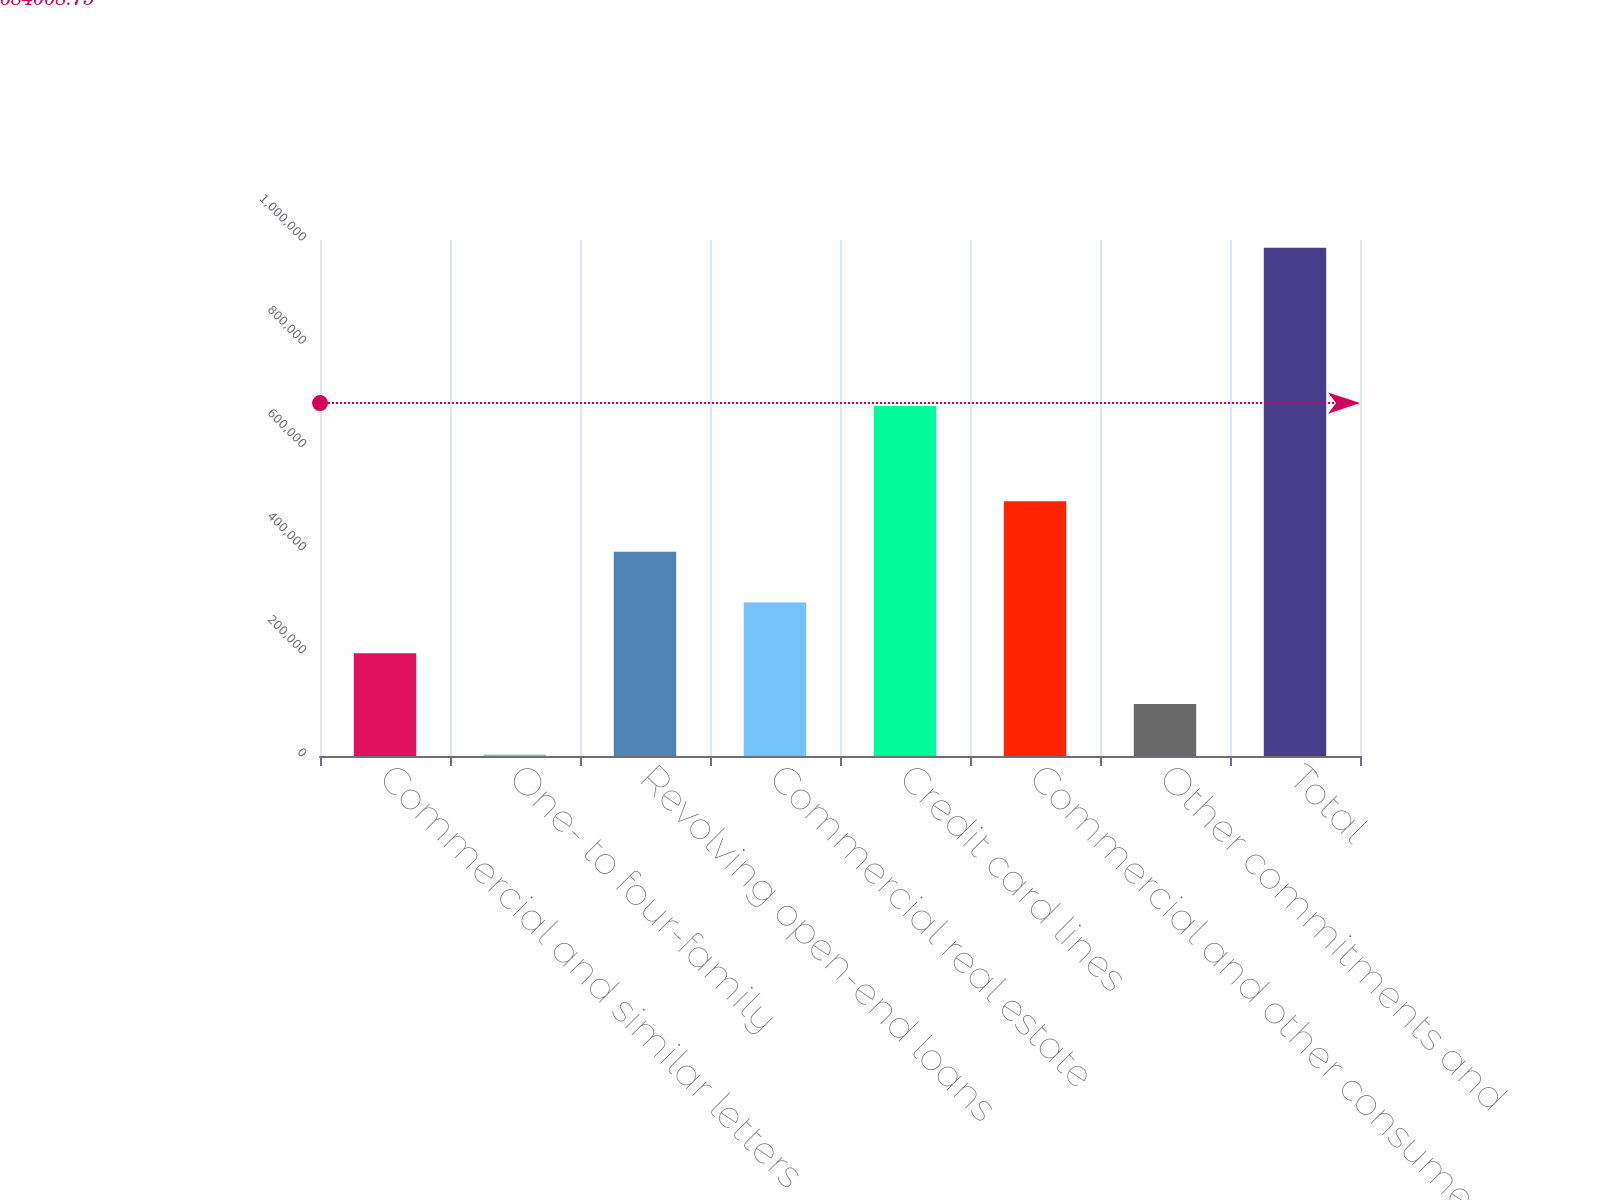Convert chart. <chart><loc_0><loc_0><loc_500><loc_500><bar_chart><fcel>Commercial and similar letters<fcel>One- to four-family<fcel>Revolving open-end loans<fcel>Commercial real estate<fcel>Credit card lines<fcel>Commercial and other consumer<fcel>Other commitments and<fcel>Total<nl><fcel>199174<fcel>2674<fcel>395674<fcel>297424<fcel>678300<fcel>493924<fcel>100924<fcel>985174<nl></chart> 